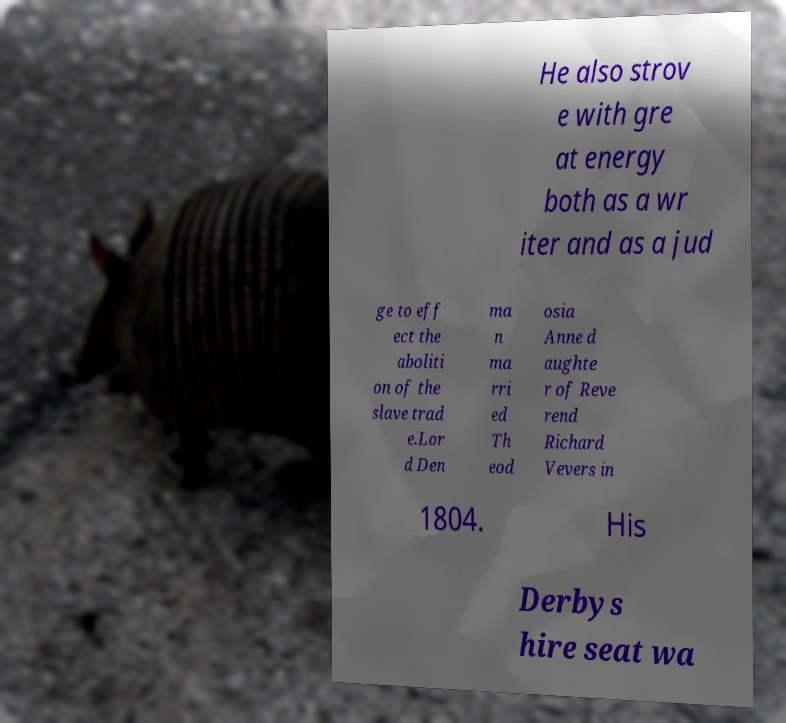Please read and relay the text visible in this image. What does it say? He also strov e with gre at energy both as a wr iter and as a jud ge to eff ect the aboliti on of the slave trad e.Lor d Den ma n ma rri ed Th eod osia Anne d aughte r of Reve rend Richard Vevers in 1804. His Derbys hire seat wa 